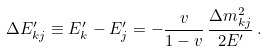Convert formula to latex. <formula><loc_0><loc_0><loc_500><loc_500>\Delta E ^ { \prime } _ { k j } \equiv E ^ { \prime } _ { k } - E ^ { \prime } _ { j } = - \frac { v } { 1 - v } \, \frac { \Delta { m } ^ { 2 } _ { k j } } { 2 E ^ { \prime } } \, .</formula> 